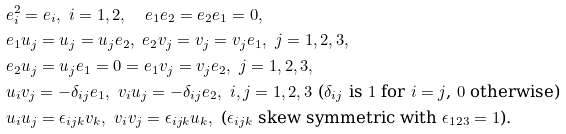Convert formula to latex. <formula><loc_0><loc_0><loc_500><loc_500>& e _ { i } ^ { 2 } = e _ { i } , \ i = 1 , 2 , \quad e _ { 1 } e _ { 2 } = e _ { 2 } e _ { 1 } = 0 , \\ & e _ { 1 } u _ { j } = u _ { j } = u _ { j } e _ { 2 } , \ e _ { 2 } v _ { j } = v _ { j } = v _ { j } e _ { 1 } , \ j = 1 , 2 , 3 , \\ & e _ { 2 } u _ { j } = u _ { j } e _ { 1 } = 0 = e _ { 1 } v _ { j } = v _ { j } e _ { 2 } , \ j = 1 , 2 , 3 , \\ & u _ { i } v _ { j } = - \delta _ { i j } e _ { 1 } , \ v _ { i } u _ { j } = - \delta _ { i j } e _ { 2 } , \ i , j = 1 , 2 , 3 \ \text {($\delta_{ij}$ is $1$ for $i=j$, $0$ otherwise)} \\ & u _ { i } u _ { j } = \epsilon _ { i j k } v _ { k } , \ v _ { i } v _ { j } = \epsilon _ { i j k } u _ { k } , \ \text {($\epsilon_{ijk}$ skew symmetric with $\epsilon_{123}=1$).}</formula> 